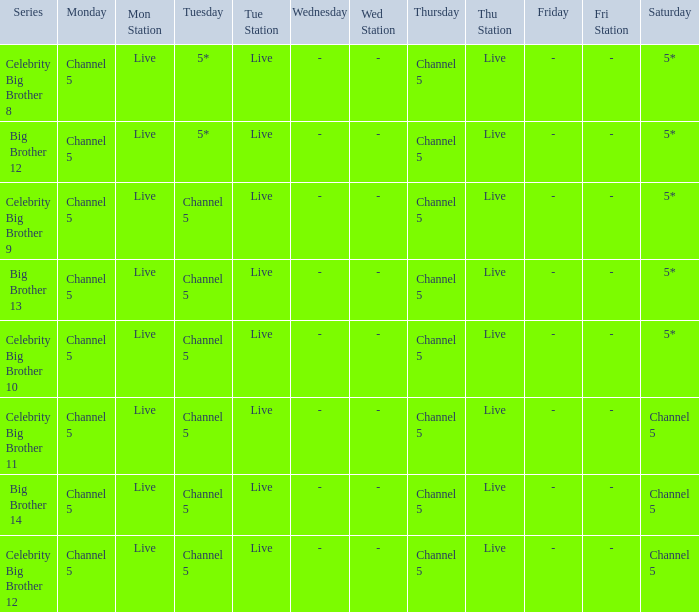Which Thursday does big brother 13 air? Channel 5. 